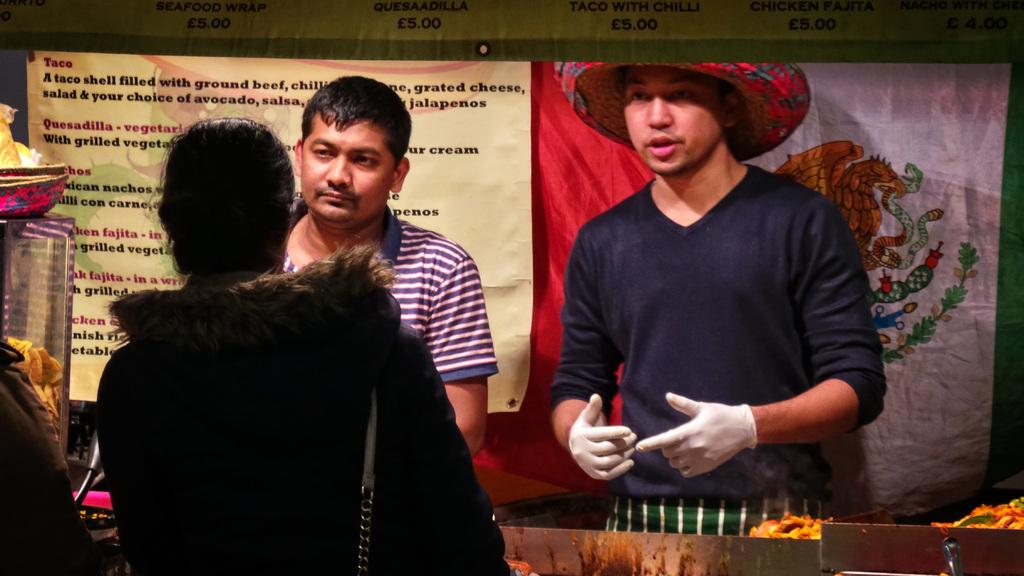How many people are in the image? There are people in the image, but the exact number is not specified. What is one person wearing that is noteworthy? One person is wearing a hat and gloves. What else can be seen in the image besides people? There are food items visible in the image. What type of decorations are present in the image? There are banners in different colors in the image. Where is the faucet located in the image? There is no faucet present in the image. What type of string is being used to hold the banners in the image? The facts provided do not mention any string being used to hold the banners in the image. 